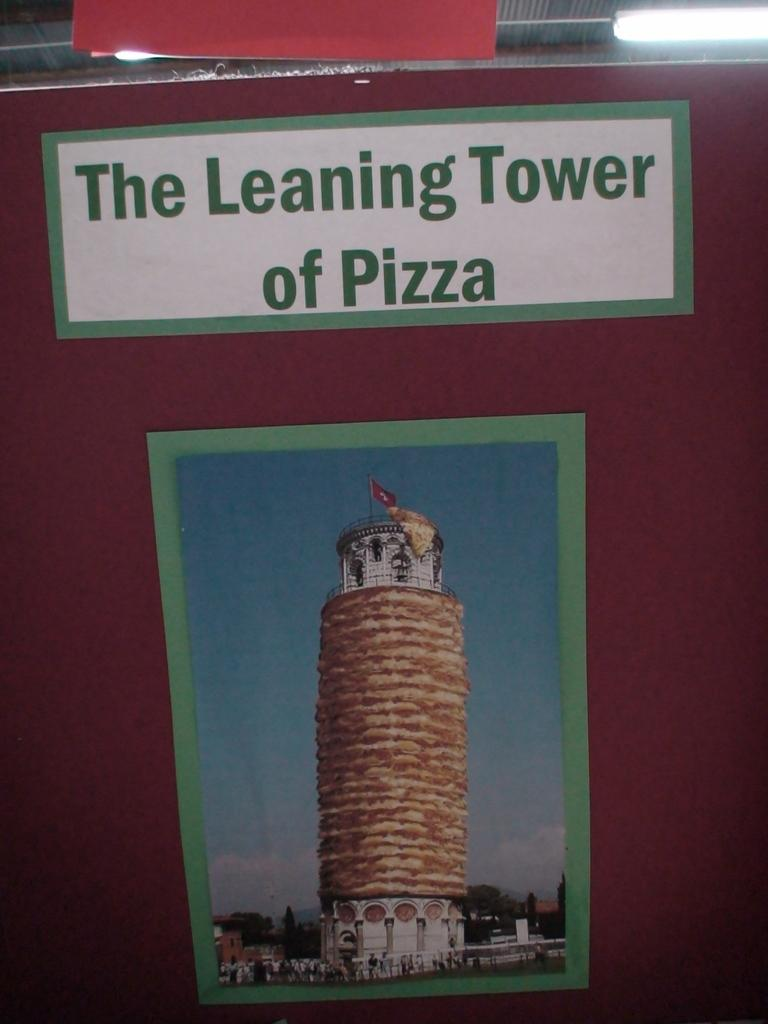<image>
Share a concise interpretation of the image provided. The photograph shown is of the famous Leaning Tower of Pizza. 